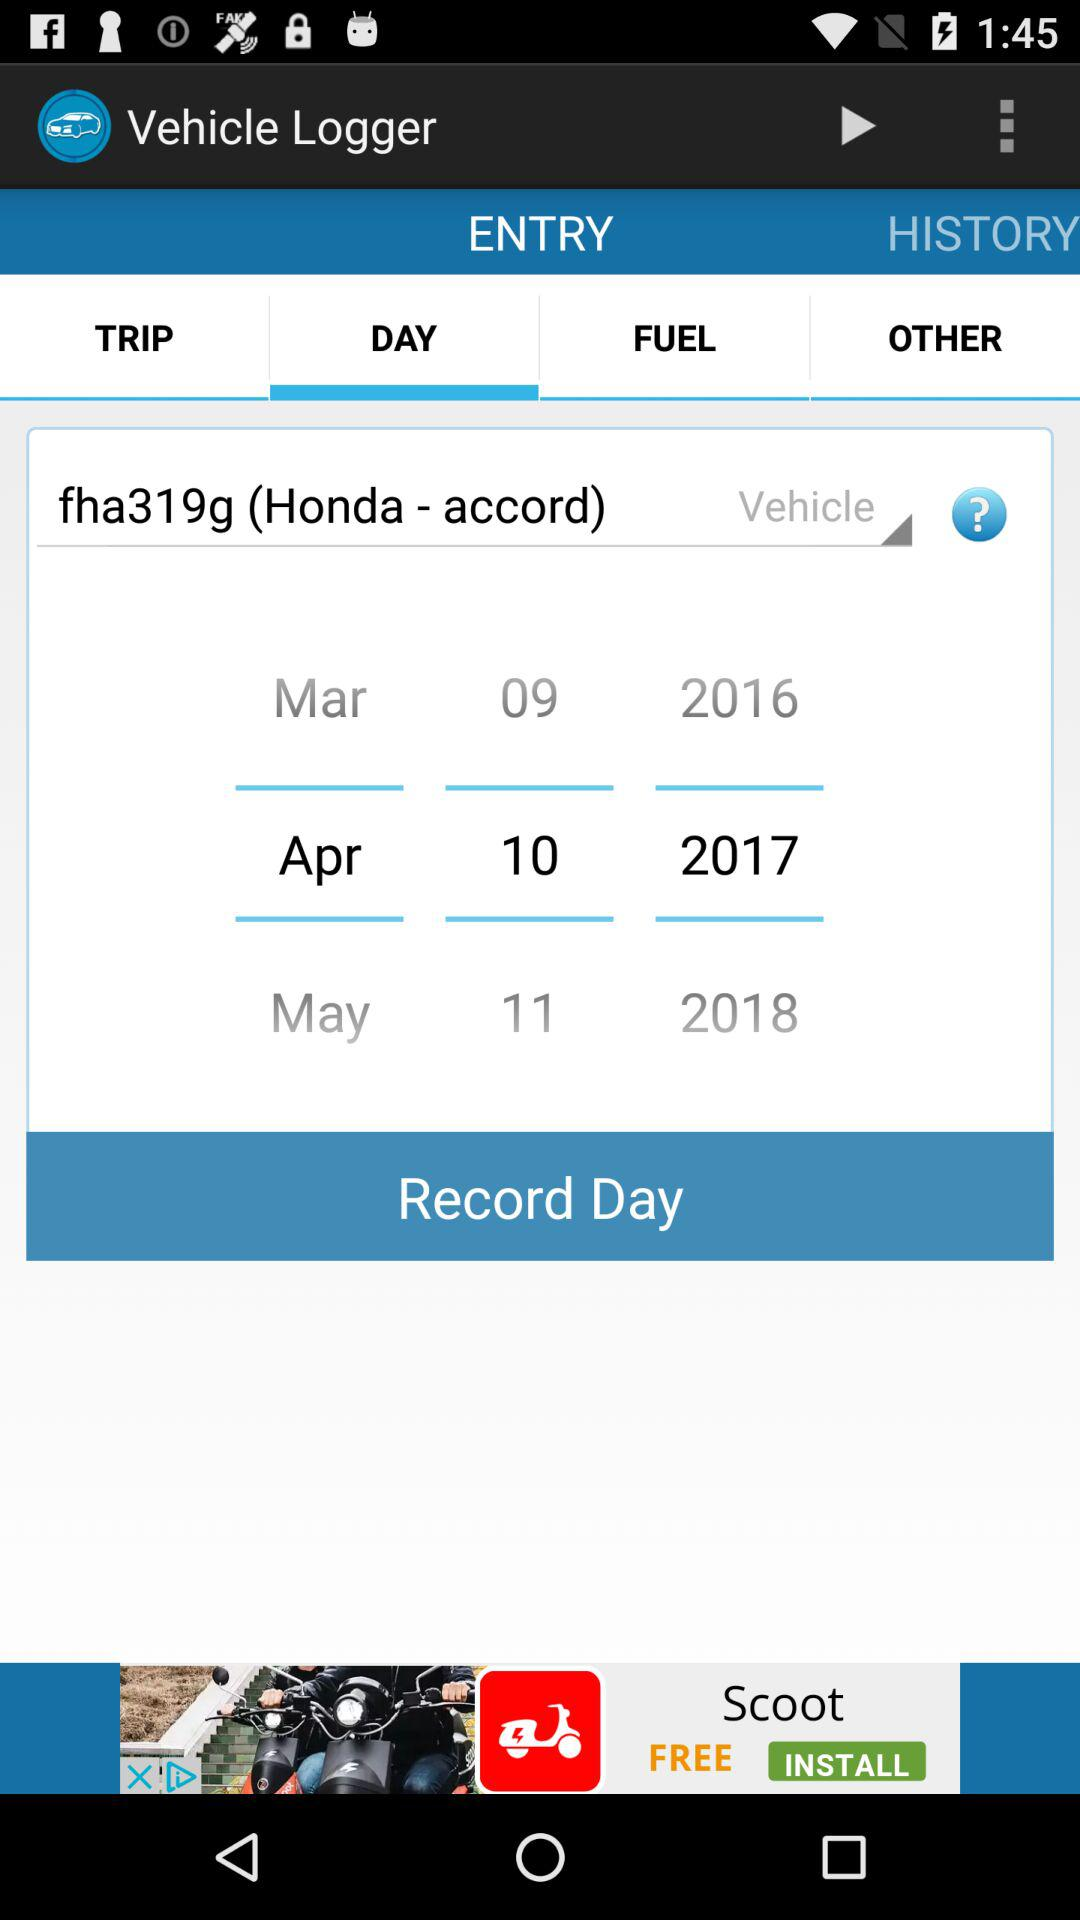On what date is the vehicle log being entered? The vehicle log is being entered on April 10, 2017. 